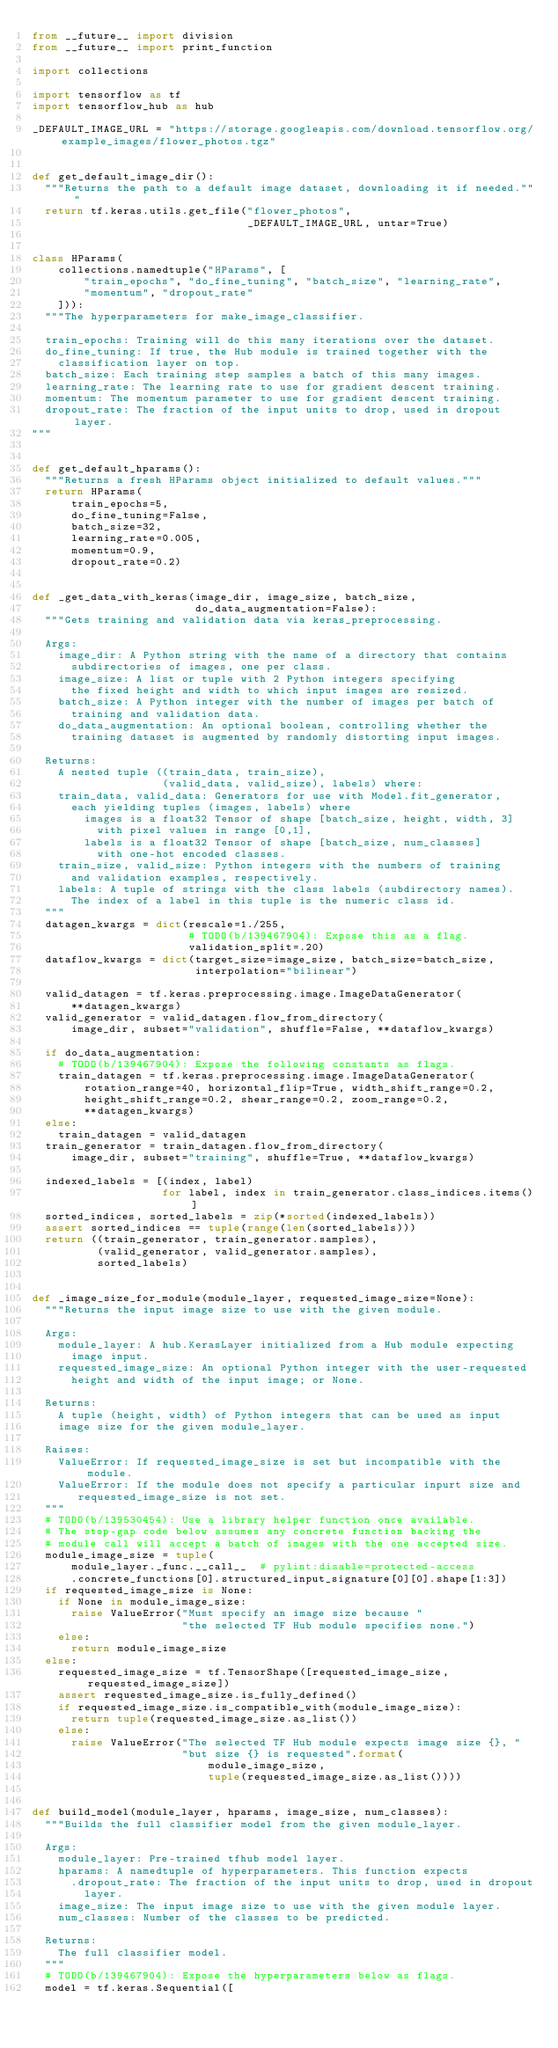Convert code to text. <code><loc_0><loc_0><loc_500><loc_500><_Python_>from __future__ import division
from __future__ import print_function

import collections

import tensorflow as tf
import tensorflow_hub as hub

_DEFAULT_IMAGE_URL = "https://storage.googleapis.com/download.tensorflow.org/example_images/flower_photos.tgz"


def get_default_image_dir():
  """Returns the path to a default image dataset, downloading it if needed."""
  return tf.keras.utils.get_file("flower_photos",
                                 _DEFAULT_IMAGE_URL, untar=True)


class HParams(
    collections.namedtuple("HParams", [
        "train_epochs", "do_fine_tuning", "batch_size", "learning_rate",
        "momentum", "dropout_rate"
    ])):
  """The hyperparameters for make_image_classifier.

  train_epochs: Training will do this many iterations over the dataset.
  do_fine_tuning: If true, the Hub module is trained together with the
    classification layer on top.
  batch_size: Each training step samples a batch of this many images.
  learning_rate: The learning rate to use for gradient descent training.
  momentum: The momentum parameter to use for gradient descent training.
  dropout_rate: The fraction of the input units to drop, used in dropout layer.
"""


def get_default_hparams():
  """Returns a fresh HParams object initialized to default values."""
  return HParams(
      train_epochs=5,
      do_fine_tuning=False,
      batch_size=32,
      learning_rate=0.005,
      momentum=0.9,
      dropout_rate=0.2)


def _get_data_with_keras(image_dir, image_size, batch_size,
                         do_data_augmentation=False):
  """Gets training and validation data via keras_preprocessing.

  Args:
    image_dir: A Python string with the name of a directory that contains
      subdirectories of images, one per class.
    image_size: A list or tuple with 2 Python integers specifying
      the fixed height and width to which input images are resized.
    batch_size: A Python integer with the number of images per batch of
      training and validation data.
    do_data_augmentation: An optional boolean, controlling whether the
      training dataset is augmented by randomly distorting input images.

  Returns:
    A nested tuple ((train_data, train_size),
                    (valid_data, valid_size), labels) where:
    train_data, valid_data: Generators for use with Model.fit_generator,
      each yielding tuples (images, labels) where
        images is a float32 Tensor of shape [batch_size, height, width, 3]
          with pixel values in range [0,1],
        labels is a float32 Tensor of shape [batch_size, num_classes]
          with one-hot encoded classes.
    train_size, valid_size: Python integers with the numbers of training
      and validation examples, respectively.
    labels: A tuple of strings with the class labels (subdirectory names).
      The index of a label in this tuple is the numeric class id.
  """
  datagen_kwargs = dict(rescale=1./255,
                        # TODO(b/139467904): Expose this as a flag.
                        validation_split=.20)
  dataflow_kwargs = dict(target_size=image_size, batch_size=batch_size,
                         interpolation="bilinear")

  valid_datagen = tf.keras.preprocessing.image.ImageDataGenerator(
      **datagen_kwargs)
  valid_generator = valid_datagen.flow_from_directory(
      image_dir, subset="validation", shuffle=False, **dataflow_kwargs)

  if do_data_augmentation:
    # TODO(b/139467904): Expose the following constants as flags.
    train_datagen = tf.keras.preprocessing.image.ImageDataGenerator(
        rotation_range=40, horizontal_flip=True, width_shift_range=0.2,
        height_shift_range=0.2, shear_range=0.2, zoom_range=0.2,
        **datagen_kwargs)
  else:
    train_datagen = valid_datagen
  train_generator = train_datagen.flow_from_directory(
      image_dir, subset="training", shuffle=True, **dataflow_kwargs)

  indexed_labels = [(index, label)
                    for label, index in train_generator.class_indices.items()]
  sorted_indices, sorted_labels = zip(*sorted(indexed_labels))
  assert sorted_indices == tuple(range(len(sorted_labels)))
  return ((train_generator, train_generator.samples),
          (valid_generator, valid_generator.samples),
          sorted_labels)


def _image_size_for_module(module_layer, requested_image_size=None):
  """Returns the input image size to use with the given module.

  Args:
    module_layer: A hub.KerasLayer initialized from a Hub module expecting
      image input.
    requested_image_size: An optional Python integer with the user-requested
      height and width of the input image; or None.

  Returns:
    A tuple (height, width) of Python integers that can be used as input
    image size for the given module_layer.

  Raises:
    ValueError: If requested_image_size is set but incompatible with the module.
    ValueError: If the module does not specify a particular inpurt size and
       requested_image_size is not set.
  """
  # TODO(b/139530454): Use a library helper function once available.
  # The stop-gap code below assumes any concrete function backing the
  # module call will accept a batch of images with the one accepted size.
  module_image_size = tuple(
      module_layer._func.__call__  # pylint:disable=protected-access
      .concrete_functions[0].structured_input_signature[0][0].shape[1:3])
  if requested_image_size is None:
    if None in module_image_size:
      raise ValueError("Must specify an image size because "
                       "the selected TF Hub module specifies none.")
    else:
      return module_image_size
  else:
    requested_image_size = tf.TensorShape([requested_image_size, requested_image_size])
    assert requested_image_size.is_fully_defined()
    if requested_image_size.is_compatible_with(module_image_size):
      return tuple(requested_image_size.as_list())
    else:
      raise ValueError("The selected TF Hub module expects image size {}, "
                       "but size {} is requested".format(
                           module_image_size,
                           tuple(requested_image_size.as_list())))


def build_model(module_layer, hparams, image_size, num_classes):
  """Builds the full classifier model from the given module_layer.

  Args:
    module_layer: Pre-trained tfhub model layer.
    hparams: A namedtuple of hyperparameters. This function expects
      .dropout_rate: The fraction of the input units to drop, used in dropout
        layer.
    image_size: The input image size to use with the given module layer.
    num_classes: Number of the classes to be predicted.

  Returns:
    The full classifier model.
  """
  # TODO(b/139467904): Expose the hyperparameters below as flags.
  model = tf.keras.Sequential([</code> 